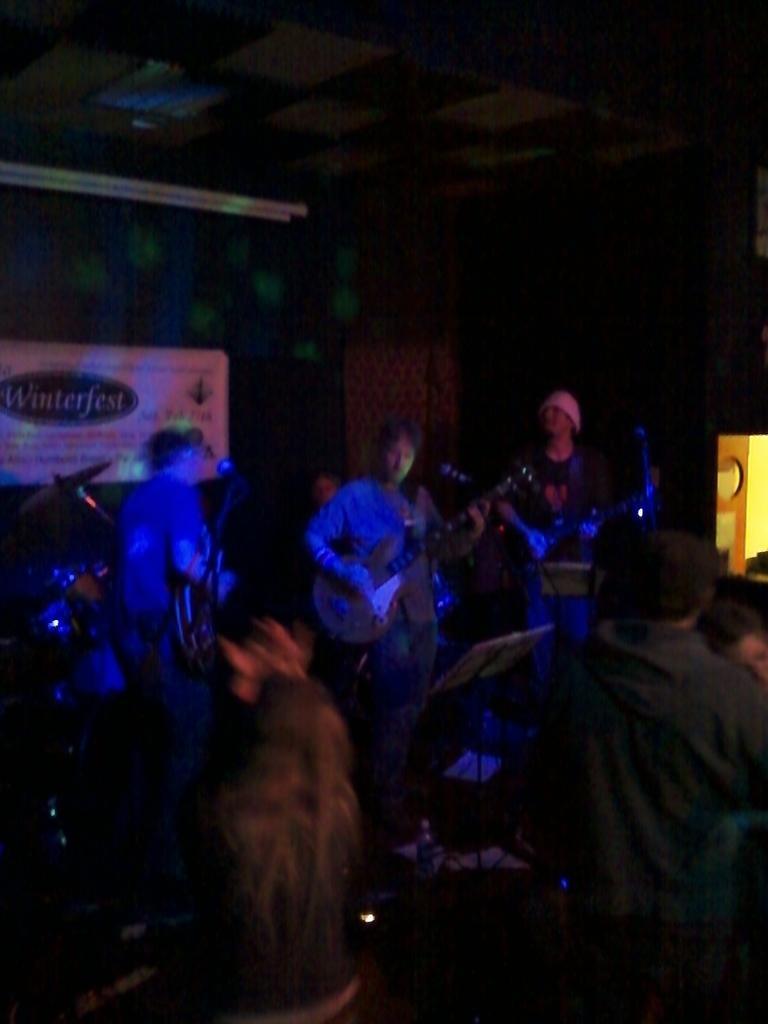Can you describe this image briefly? In the picture it looks like some event and few people are playing the music instruments, there is a blue light focusing on them, behind he people there is a banner. 